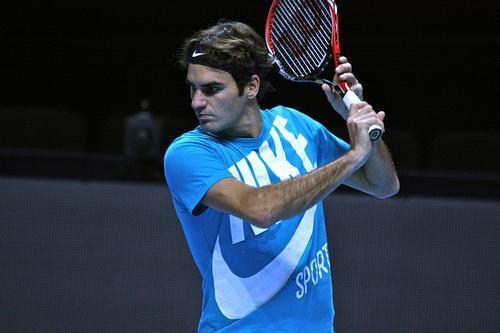How many rackets are on the right of the person?
Give a very brief answer. 1. 